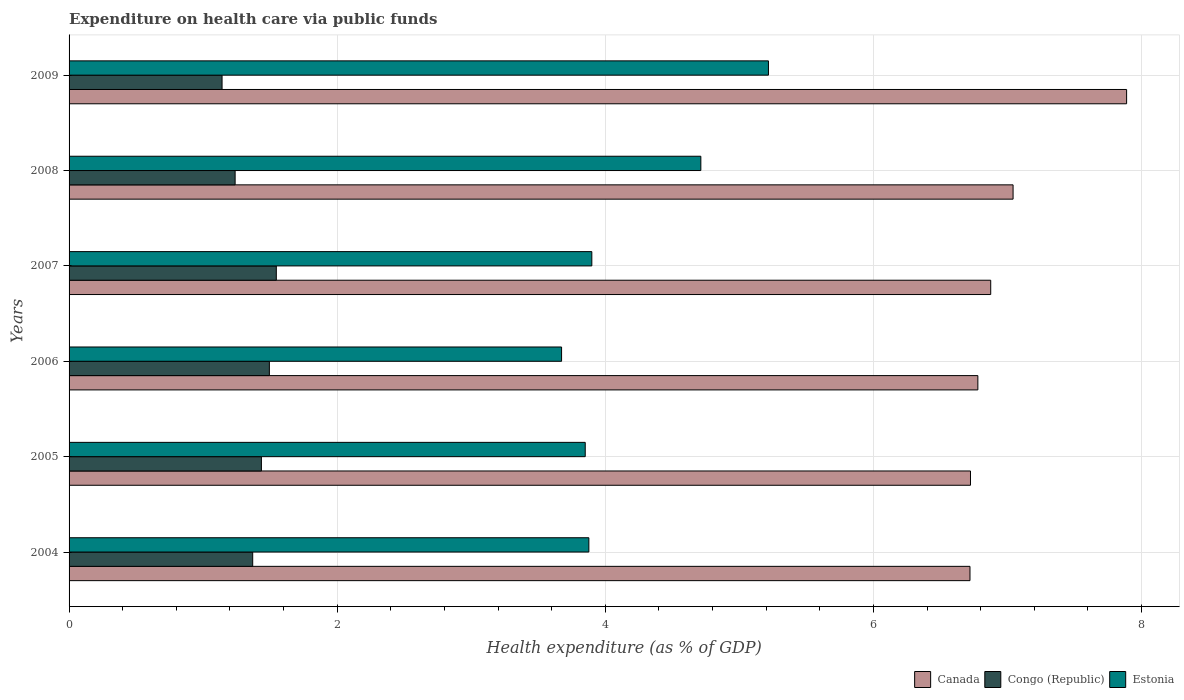How many groups of bars are there?
Keep it short and to the point. 6. Are the number of bars per tick equal to the number of legend labels?
Give a very brief answer. Yes. How many bars are there on the 5th tick from the top?
Ensure brevity in your answer.  3. In how many cases, is the number of bars for a given year not equal to the number of legend labels?
Keep it short and to the point. 0. What is the expenditure made on health care in Congo (Republic) in 2007?
Make the answer very short. 1.55. Across all years, what is the maximum expenditure made on health care in Estonia?
Ensure brevity in your answer.  5.22. Across all years, what is the minimum expenditure made on health care in Congo (Republic)?
Your answer should be very brief. 1.14. In which year was the expenditure made on health care in Canada maximum?
Offer a terse response. 2009. What is the total expenditure made on health care in Congo (Republic) in the graph?
Your answer should be very brief. 8.22. What is the difference between the expenditure made on health care in Canada in 2004 and that in 2005?
Your response must be concise. -0. What is the difference between the expenditure made on health care in Estonia in 2006 and the expenditure made on health care in Congo (Republic) in 2009?
Your response must be concise. 2.53. What is the average expenditure made on health care in Estonia per year?
Your answer should be compact. 4.2. In the year 2004, what is the difference between the expenditure made on health care in Congo (Republic) and expenditure made on health care in Estonia?
Provide a succinct answer. -2.51. In how many years, is the expenditure made on health care in Estonia greater than 6 %?
Make the answer very short. 0. What is the ratio of the expenditure made on health care in Estonia in 2008 to that in 2009?
Offer a terse response. 0.9. What is the difference between the highest and the second highest expenditure made on health care in Estonia?
Provide a succinct answer. 0.5. What is the difference between the highest and the lowest expenditure made on health care in Estonia?
Provide a short and direct response. 1.54. What does the 2nd bar from the top in 2007 represents?
Your answer should be compact. Congo (Republic). What does the 1st bar from the bottom in 2005 represents?
Provide a short and direct response. Canada. How many bars are there?
Ensure brevity in your answer.  18. Are the values on the major ticks of X-axis written in scientific E-notation?
Ensure brevity in your answer.  No. Does the graph contain any zero values?
Ensure brevity in your answer.  No. How many legend labels are there?
Provide a succinct answer. 3. What is the title of the graph?
Make the answer very short. Expenditure on health care via public funds. What is the label or title of the X-axis?
Ensure brevity in your answer.  Health expenditure (as % of GDP). What is the label or title of the Y-axis?
Your answer should be very brief. Years. What is the Health expenditure (as % of GDP) of Canada in 2004?
Offer a very short reply. 6.72. What is the Health expenditure (as % of GDP) of Congo (Republic) in 2004?
Offer a terse response. 1.37. What is the Health expenditure (as % of GDP) of Estonia in 2004?
Give a very brief answer. 3.88. What is the Health expenditure (as % of GDP) in Canada in 2005?
Provide a succinct answer. 6.72. What is the Health expenditure (as % of GDP) of Congo (Republic) in 2005?
Keep it short and to the point. 1.43. What is the Health expenditure (as % of GDP) of Estonia in 2005?
Your answer should be compact. 3.85. What is the Health expenditure (as % of GDP) in Canada in 2006?
Ensure brevity in your answer.  6.78. What is the Health expenditure (as % of GDP) in Congo (Republic) in 2006?
Offer a terse response. 1.49. What is the Health expenditure (as % of GDP) of Estonia in 2006?
Provide a short and direct response. 3.67. What is the Health expenditure (as % of GDP) in Canada in 2007?
Offer a terse response. 6.87. What is the Health expenditure (as % of GDP) of Congo (Republic) in 2007?
Ensure brevity in your answer.  1.55. What is the Health expenditure (as % of GDP) of Estonia in 2007?
Make the answer very short. 3.9. What is the Health expenditure (as % of GDP) in Canada in 2008?
Offer a very short reply. 7.04. What is the Health expenditure (as % of GDP) of Congo (Republic) in 2008?
Ensure brevity in your answer.  1.24. What is the Health expenditure (as % of GDP) in Estonia in 2008?
Make the answer very short. 4.71. What is the Health expenditure (as % of GDP) in Canada in 2009?
Offer a very short reply. 7.89. What is the Health expenditure (as % of GDP) in Congo (Republic) in 2009?
Provide a succinct answer. 1.14. What is the Health expenditure (as % of GDP) of Estonia in 2009?
Your response must be concise. 5.22. Across all years, what is the maximum Health expenditure (as % of GDP) of Canada?
Your answer should be very brief. 7.89. Across all years, what is the maximum Health expenditure (as % of GDP) in Congo (Republic)?
Make the answer very short. 1.55. Across all years, what is the maximum Health expenditure (as % of GDP) of Estonia?
Make the answer very short. 5.22. Across all years, what is the minimum Health expenditure (as % of GDP) in Canada?
Ensure brevity in your answer.  6.72. Across all years, what is the minimum Health expenditure (as % of GDP) in Congo (Republic)?
Provide a succinct answer. 1.14. Across all years, what is the minimum Health expenditure (as % of GDP) of Estonia?
Offer a very short reply. 3.67. What is the total Health expenditure (as % of GDP) of Canada in the graph?
Make the answer very short. 42.03. What is the total Health expenditure (as % of GDP) of Congo (Republic) in the graph?
Your response must be concise. 8.22. What is the total Health expenditure (as % of GDP) in Estonia in the graph?
Your response must be concise. 25.23. What is the difference between the Health expenditure (as % of GDP) of Canada in 2004 and that in 2005?
Provide a succinct answer. -0. What is the difference between the Health expenditure (as % of GDP) in Congo (Republic) in 2004 and that in 2005?
Give a very brief answer. -0.06. What is the difference between the Health expenditure (as % of GDP) in Estonia in 2004 and that in 2005?
Ensure brevity in your answer.  0.03. What is the difference between the Health expenditure (as % of GDP) of Canada in 2004 and that in 2006?
Offer a terse response. -0.06. What is the difference between the Health expenditure (as % of GDP) of Congo (Republic) in 2004 and that in 2006?
Your response must be concise. -0.12. What is the difference between the Health expenditure (as % of GDP) of Estonia in 2004 and that in 2006?
Offer a terse response. 0.2. What is the difference between the Health expenditure (as % of GDP) of Canada in 2004 and that in 2007?
Give a very brief answer. -0.15. What is the difference between the Health expenditure (as % of GDP) in Congo (Republic) in 2004 and that in 2007?
Ensure brevity in your answer.  -0.18. What is the difference between the Health expenditure (as % of GDP) of Estonia in 2004 and that in 2007?
Provide a succinct answer. -0.02. What is the difference between the Health expenditure (as % of GDP) in Canada in 2004 and that in 2008?
Ensure brevity in your answer.  -0.32. What is the difference between the Health expenditure (as % of GDP) of Congo (Republic) in 2004 and that in 2008?
Your answer should be very brief. 0.13. What is the difference between the Health expenditure (as % of GDP) in Estonia in 2004 and that in 2008?
Your answer should be very brief. -0.84. What is the difference between the Health expenditure (as % of GDP) of Canada in 2004 and that in 2009?
Your response must be concise. -1.17. What is the difference between the Health expenditure (as % of GDP) in Congo (Republic) in 2004 and that in 2009?
Your answer should be very brief. 0.23. What is the difference between the Health expenditure (as % of GDP) in Estonia in 2004 and that in 2009?
Your answer should be very brief. -1.34. What is the difference between the Health expenditure (as % of GDP) of Canada in 2005 and that in 2006?
Provide a succinct answer. -0.06. What is the difference between the Health expenditure (as % of GDP) of Congo (Republic) in 2005 and that in 2006?
Ensure brevity in your answer.  -0.06. What is the difference between the Health expenditure (as % of GDP) in Estonia in 2005 and that in 2006?
Ensure brevity in your answer.  0.18. What is the difference between the Health expenditure (as % of GDP) in Canada in 2005 and that in 2007?
Ensure brevity in your answer.  -0.15. What is the difference between the Health expenditure (as % of GDP) of Congo (Republic) in 2005 and that in 2007?
Your answer should be very brief. -0.11. What is the difference between the Health expenditure (as % of GDP) of Estonia in 2005 and that in 2007?
Offer a very short reply. -0.05. What is the difference between the Health expenditure (as % of GDP) in Canada in 2005 and that in 2008?
Provide a succinct answer. -0.32. What is the difference between the Health expenditure (as % of GDP) in Congo (Republic) in 2005 and that in 2008?
Offer a very short reply. 0.2. What is the difference between the Health expenditure (as % of GDP) of Estonia in 2005 and that in 2008?
Your answer should be compact. -0.86. What is the difference between the Health expenditure (as % of GDP) in Canada in 2005 and that in 2009?
Ensure brevity in your answer.  -1.16. What is the difference between the Health expenditure (as % of GDP) in Congo (Republic) in 2005 and that in 2009?
Ensure brevity in your answer.  0.29. What is the difference between the Health expenditure (as % of GDP) of Estonia in 2005 and that in 2009?
Offer a terse response. -1.37. What is the difference between the Health expenditure (as % of GDP) in Canada in 2006 and that in 2007?
Provide a succinct answer. -0.1. What is the difference between the Health expenditure (as % of GDP) of Congo (Republic) in 2006 and that in 2007?
Offer a terse response. -0.05. What is the difference between the Health expenditure (as % of GDP) in Estonia in 2006 and that in 2007?
Your response must be concise. -0.23. What is the difference between the Health expenditure (as % of GDP) in Canada in 2006 and that in 2008?
Offer a very short reply. -0.26. What is the difference between the Health expenditure (as % of GDP) in Congo (Republic) in 2006 and that in 2008?
Your answer should be compact. 0.26. What is the difference between the Health expenditure (as % of GDP) of Estonia in 2006 and that in 2008?
Ensure brevity in your answer.  -1.04. What is the difference between the Health expenditure (as % of GDP) of Canada in 2006 and that in 2009?
Provide a succinct answer. -1.11. What is the difference between the Health expenditure (as % of GDP) of Congo (Republic) in 2006 and that in 2009?
Keep it short and to the point. 0.35. What is the difference between the Health expenditure (as % of GDP) in Estonia in 2006 and that in 2009?
Offer a very short reply. -1.54. What is the difference between the Health expenditure (as % of GDP) of Canada in 2007 and that in 2008?
Your answer should be very brief. -0.17. What is the difference between the Health expenditure (as % of GDP) of Congo (Republic) in 2007 and that in 2008?
Your answer should be very brief. 0.31. What is the difference between the Health expenditure (as % of GDP) of Estonia in 2007 and that in 2008?
Your response must be concise. -0.81. What is the difference between the Health expenditure (as % of GDP) of Canada in 2007 and that in 2009?
Offer a terse response. -1.01. What is the difference between the Health expenditure (as % of GDP) in Congo (Republic) in 2007 and that in 2009?
Offer a terse response. 0.4. What is the difference between the Health expenditure (as % of GDP) in Estonia in 2007 and that in 2009?
Provide a short and direct response. -1.32. What is the difference between the Health expenditure (as % of GDP) in Canada in 2008 and that in 2009?
Offer a very short reply. -0.85. What is the difference between the Health expenditure (as % of GDP) in Congo (Republic) in 2008 and that in 2009?
Offer a very short reply. 0.1. What is the difference between the Health expenditure (as % of GDP) of Estonia in 2008 and that in 2009?
Ensure brevity in your answer.  -0.5. What is the difference between the Health expenditure (as % of GDP) of Canada in 2004 and the Health expenditure (as % of GDP) of Congo (Republic) in 2005?
Make the answer very short. 5.29. What is the difference between the Health expenditure (as % of GDP) in Canada in 2004 and the Health expenditure (as % of GDP) in Estonia in 2005?
Offer a very short reply. 2.87. What is the difference between the Health expenditure (as % of GDP) in Congo (Republic) in 2004 and the Health expenditure (as % of GDP) in Estonia in 2005?
Keep it short and to the point. -2.48. What is the difference between the Health expenditure (as % of GDP) of Canada in 2004 and the Health expenditure (as % of GDP) of Congo (Republic) in 2006?
Your answer should be compact. 5.23. What is the difference between the Health expenditure (as % of GDP) in Canada in 2004 and the Health expenditure (as % of GDP) in Estonia in 2006?
Offer a very short reply. 3.05. What is the difference between the Health expenditure (as % of GDP) of Congo (Republic) in 2004 and the Health expenditure (as % of GDP) of Estonia in 2006?
Provide a succinct answer. -2.3. What is the difference between the Health expenditure (as % of GDP) in Canada in 2004 and the Health expenditure (as % of GDP) in Congo (Republic) in 2007?
Your answer should be compact. 5.17. What is the difference between the Health expenditure (as % of GDP) of Canada in 2004 and the Health expenditure (as % of GDP) of Estonia in 2007?
Keep it short and to the point. 2.82. What is the difference between the Health expenditure (as % of GDP) in Congo (Republic) in 2004 and the Health expenditure (as % of GDP) in Estonia in 2007?
Your answer should be compact. -2.53. What is the difference between the Health expenditure (as % of GDP) in Canada in 2004 and the Health expenditure (as % of GDP) in Congo (Republic) in 2008?
Offer a very short reply. 5.48. What is the difference between the Health expenditure (as % of GDP) in Canada in 2004 and the Health expenditure (as % of GDP) in Estonia in 2008?
Your answer should be compact. 2.01. What is the difference between the Health expenditure (as % of GDP) of Congo (Republic) in 2004 and the Health expenditure (as % of GDP) of Estonia in 2008?
Offer a very short reply. -3.34. What is the difference between the Health expenditure (as % of GDP) of Canada in 2004 and the Health expenditure (as % of GDP) of Congo (Republic) in 2009?
Offer a very short reply. 5.58. What is the difference between the Health expenditure (as % of GDP) in Canada in 2004 and the Health expenditure (as % of GDP) in Estonia in 2009?
Your answer should be compact. 1.5. What is the difference between the Health expenditure (as % of GDP) in Congo (Republic) in 2004 and the Health expenditure (as % of GDP) in Estonia in 2009?
Provide a succinct answer. -3.85. What is the difference between the Health expenditure (as % of GDP) in Canada in 2005 and the Health expenditure (as % of GDP) in Congo (Republic) in 2006?
Your response must be concise. 5.23. What is the difference between the Health expenditure (as % of GDP) of Canada in 2005 and the Health expenditure (as % of GDP) of Estonia in 2006?
Ensure brevity in your answer.  3.05. What is the difference between the Health expenditure (as % of GDP) in Congo (Republic) in 2005 and the Health expenditure (as % of GDP) in Estonia in 2006?
Your answer should be compact. -2.24. What is the difference between the Health expenditure (as % of GDP) of Canada in 2005 and the Health expenditure (as % of GDP) of Congo (Republic) in 2007?
Make the answer very short. 5.18. What is the difference between the Health expenditure (as % of GDP) in Canada in 2005 and the Health expenditure (as % of GDP) in Estonia in 2007?
Your answer should be very brief. 2.82. What is the difference between the Health expenditure (as % of GDP) of Congo (Republic) in 2005 and the Health expenditure (as % of GDP) of Estonia in 2007?
Provide a short and direct response. -2.46. What is the difference between the Health expenditure (as % of GDP) of Canada in 2005 and the Health expenditure (as % of GDP) of Congo (Republic) in 2008?
Provide a short and direct response. 5.49. What is the difference between the Health expenditure (as % of GDP) in Canada in 2005 and the Health expenditure (as % of GDP) in Estonia in 2008?
Give a very brief answer. 2.01. What is the difference between the Health expenditure (as % of GDP) in Congo (Republic) in 2005 and the Health expenditure (as % of GDP) in Estonia in 2008?
Your answer should be very brief. -3.28. What is the difference between the Health expenditure (as % of GDP) of Canada in 2005 and the Health expenditure (as % of GDP) of Congo (Republic) in 2009?
Offer a very short reply. 5.58. What is the difference between the Health expenditure (as % of GDP) of Canada in 2005 and the Health expenditure (as % of GDP) of Estonia in 2009?
Offer a terse response. 1.51. What is the difference between the Health expenditure (as % of GDP) of Congo (Republic) in 2005 and the Health expenditure (as % of GDP) of Estonia in 2009?
Make the answer very short. -3.78. What is the difference between the Health expenditure (as % of GDP) in Canada in 2006 and the Health expenditure (as % of GDP) in Congo (Republic) in 2007?
Your answer should be very brief. 5.23. What is the difference between the Health expenditure (as % of GDP) in Canada in 2006 and the Health expenditure (as % of GDP) in Estonia in 2007?
Your answer should be very brief. 2.88. What is the difference between the Health expenditure (as % of GDP) of Congo (Republic) in 2006 and the Health expenditure (as % of GDP) of Estonia in 2007?
Your response must be concise. -2.41. What is the difference between the Health expenditure (as % of GDP) of Canada in 2006 and the Health expenditure (as % of GDP) of Congo (Republic) in 2008?
Your answer should be compact. 5.54. What is the difference between the Health expenditure (as % of GDP) in Canada in 2006 and the Health expenditure (as % of GDP) in Estonia in 2008?
Provide a short and direct response. 2.07. What is the difference between the Health expenditure (as % of GDP) of Congo (Republic) in 2006 and the Health expenditure (as % of GDP) of Estonia in 2008?
Provide a short and direct response. -3.22. What is the difference between the Health expenditure (as % of GDP) of Canada in 2006 and the Health expenditure (as % of GDP) of Congo (Republic) in 2009?
Your response must be concise. 5.64. What is the difference between the Health expenditure (as % of GDP) in Canada in 2006 and the Health expenditure (as % of GDP) in Estonia in 2009?
Your answer should be very brief. 1.56. What is the difference between the Health expenditure (as % of GDP) in Congo (Republic) in 2006 and the Health expenditure (as % of GDP) in Estonia in 2009?
Your answer should be very brief. -3.72. What is the difference between the Health expenditure (as % of GDP) in Canada in 2007 and the Health expenditure (as % of GDP) in Congo (Republic) in 2008?
Your answer should be compact. 5.64. What is the difference between the Health expenditure (as % of GDP) in Canada in 2007 and the Health expenditure (as % of GDP) in Estonia in 2008?
Your response must be concise. 2.16. What is the difference between the Health expenditure (as % of GDP) of Congo (Republic) in 2007 and the Health expenditure (as % of GDP) of Estonia in 2008?
Keep it short and to the point. -3.17. What is the difference between the Health expenditure (as % of GDP) in Canada in 2007 and the Health expenditure (as % of GDP) in Congo (Republic) in 2009?
Ensure brevity in your answer.  5.73. What is the difference between the Health expenditure (as % of GDP) of Canada in 2007 and the Health expenditure (as % of GDP) of Estonia in 2009?
Keep it short and to the point. 1.66. What is the difference between the Health expenditure (as % of GDP) of Congo (Republic) in 2007 and the Health expenditure (as % of GDP) of Estonia in 2009?
Offer a very short reply. -3.67. What is the difference between the Health expenditure (as % of GDP) in Canada in 2008 and the Health expenditure (as % of GDP) in Congo (Republic) in 2009?
Make the answer very short. 5.9. What is the difference between the Health expenditure (as % of GDP) in Canada in 2008 and the Health expenditure (as % of GDP) in Estonia in 2009?
Offer a terse response. 1.82. What is the difference between the Health expenditure (as % of GDP) of Congo (Republic) in 2008 and the Health expenditure (as % of GDP) of Estonia in 2009?
Keep it short and to the point. -3.98. What is the average Health expenditure (as % of GDP) of Canada per year?
Provide a short and direct response. 7. What is the average Health expenditure (as % of GDP) in Congo (Republic) per year?
Provide a succinct answer. 1.37. What is the average Health expenditure (as % of GDP) in Estonia per year?
Keep it short and to the point. 4.2. In the year 2004, what is the difference between the Health expenditure (as % of GDP) in Canada and Health expenditure (as % of GDP) in Congo (Republic)?
Your response must be concise. 5.35. In the year 2004, what is the difference between the Health expenditure (as % of GDP) of Canada and Health expenditure (as % of GDP) of Estonia?
Provide a short and direct response. 2.84. In the year 2004, what is the difference between the Health expenditure (as % of GDP) in Congo (Republic) and Health expenditure (as % of GDP) in Estonia?
Your answer should be compact. -2.51. In the year 2005, what is the difference between the Health expenditure (as % of GDP) of Canada and Health expenditure (as % of GDP) of Congo (Republic)?
Your response must be concise. 5.29. In the year 2005, what is the difference between the Health expenditure (as % of GDP) of Canada and Health expenditure (as % of GDP) of Estonia?
Provide a short and direct response. 2.87. In the year 2005, what is the difference between the Health expenditure (as % of GDP) in Congo (Republic) and Health expenditure (as % of GDP) in Estonia?
Offer a very short reply. -2.42. In the year 2006, what is the difference between the Health expenditure (as % of GDP) of Canada and Health expenditure (as % of GDP) of Congo (Republic)?
Offer a very short reply. 5.28. In the year 2006, what is the difference between the Health expenditure (as % of GDP) in Canada and Health expenditure (as % of GDP) in Estonia?
Ensure brevity in your answer.  3.11. In the year 2006, what is the difference between the Health expenditure (as % of GDP) of Congo (Republic) and Health expenditure (as % of GDP) of Estonia?
Provide a short and direct response. -2.18. In the year 2007, what is the difference between the Health expenditure (as % of GDP) in Canada and Health expenditure (as % of GDP) in Congo (Republic)?
Your answer should be compact. 5.33. In the year 2007, what is the difference between the Health expenditure (as % of GDP) in Canada and Health expenditure (as % of GDP) in Estonia?
Provide a succinct answer. 2.98. In the year 2007, what is the difference between the Health expenditure (as % of GDP) of Congo (Republic) and Health expenditure (as % of GDP) of Estonia?
Provide a succinct answer. -2.35. In the year 2008, what is the difference between the Health expenditure (as % of GDP) of Canada and Health expenditure (as % of GDP) of Congo (Republic)?
Your answer should be very brief. 5.8. In the year 2008, what is the difference between the Health expenditure (as % of GDP) in Canada and Health expenditure (as % of GDP) in Estonia?
Provide a short and direct response. 2.33. In the year 2008, what is the difference between the Health expenditure (as % of GDP) in Congo (Republic) and Health expenditure (as % of GDP) in Estonia?
Ensure brevity in your answer.  -3.47. In the year 2009, what is the difference between the Health expenditure (as % of GDP) in Canada and Health expenditure (as % of GDP) in Congo (Republic)?
Offer a very short reply. 6.75. In the year 2009, what is the difference between the Health expenditure (as % of GDP) in Canada and Health expenditure (as % of GDP) in Estonia?
Keep it short and to the point. 2.67. In the year 2009, what is the difference between the Health expenditure (as % of GDP) in Congo (Republic) and Health expenditure (as % of GDP) in Estonia?
Your answer should be compact. -4.08. What is the ratio of the Health expenditure (as % of GDP) in Canada in 2004 to that in 2005?
Offer a very short reply. 1. What is the ratio of the Health expenditure (as % of GDP) of Congo (Republic) in 2004 to that in 2005?
Make the answer very short. 0.95. What is the ratio of the Health expenditure (as % of GDP) of Estonia in 2004 to that in 2005?
Offer a very short reply. 1.01. What is the ratio of the Health expenditure (as % of GDP) of Congo (Republic) in 2004 to that in 2006?
Offer a very short reply. 0.92. What is the ratio of the Health expenditure (as % of GDP) of Estonia in 2004 to that in 2006?
Keep it short and to the point. 1.06. What is the ratio of the Health expenditure (as % of GDP) of Canada in 2004 to that in 2007?
Offer a very short reply. 0.98. What is the ratio of the Health expenditure (as % of GDP) in Congo (Republic) in 2004 to that in 2007?
Your answer should be very brief. 0.89. What is the ratio of the Health expenditure (as % of GDP) in Canada in 2004 to that in 2008?
Ensure brevity in your answer.  0.95. What is the ratio of the Health expenditure (as % of GDP) in Congo (Republic) in 2004 to that in 2008?
Offer a terse response. 1.11. What is the ratio of the Health expenditure (as % of GDP) in Estonia in 2004 to that in 2008?
Give a very brief answer. 0.82. What is the ratio of the Health expenditure (as % of GDP) of Canada in 2004 to that in 2009?
Make the answer very short. 0.85. What is the ratio of the Health expenditure (as % of GDP) in Congo (Republic) in 2004 to that in 2009?
Your response must be concise. 1.2. What is the ratio of the Health expenditure (as % of GDP) in Estonia in 2004 to that in 2009?
Provide a short and direct response. 0.74. What is the ratio of the Health expenditure (as % of GDP) of Congo (Republic) in 2005 to that in 2006?
Your response must be concise. 0.96. What is the ratio of the Health expenditure (as % of GDP) of Estonia in 2005 to that in 2006?
Provide a short and direct response. 1.05. What is the ratio of the Health expenditure (as % of GDP) of Congo (Republic) in 2005 to that in 2007?
Provide a short and direct response. 0.93. What is the ratio of the Health expenditure (as % of GDP) in Estonia in 2005 to that in 2007?
Keep it short and to the point. 0.99. What is the ratio of the Health expenditure (as % of GDP) in Canada in 2005 to that in 2008?
Ensure brevity in your answer.  0.95. What is the ratio of the Health expenditure (as % of GDP) of Congo (Republic) in 2005 to that in 2008?
Ensure brevity in your answer.  1.16. What is the ratio of the Health expenditure (as % of GDP) of Estonia in 2005 to that in 2008?
Provide a short and direct response. 0.82. What is the ratio of the Health expenditure (as % of GDP) of Canada in 2005 to that in 2009?
Your response must be concise. 0.85. What is the ratio of the Health expenditure (as % of GDP) in Congo (Republic) in 2005 to that in 2009?
Your answer should be very brief. 1.26. What is the ratio of the Health expenditure (as % of GDP) of Estonia in 2005 to that in 2009?
Make the answer very short. 0.74. What is the ratio of the Health expenditure (as % of GDP) in Canada in 2006 to that in 2007?
Provide a short and direct response. 0.99. What is the ratio of the Health expenditure (as % of GDP) of Congo (Republic) in 2006 to that in 2007?
Ensure brevity in your answer.  0.97. What is the ratio of the Health expenditure (as % of GDP) of Estonia in 2006 to that in 2007?
Your response must be concise. 0.94. What is the ratio of the Health expenditure (as % of GDP) in Canada in 2006 to that in 2008?
Offer a very short reply. 0.96. What is the ratio of the Health expenditure (as % of GDP) of Congo (Republic) in 2006 to that in 2008?
Provide a succinct answer. 1.21. What is the ratio of the Health expenditure (as % of GDP) of Estonia in 2006 to that in 2008?
Provide a succinct answer. 0.78. What is the ratio of the Health expenditure (as % of GDP) in Canada in 2006 to that in 2009?
Your response must be concise. 0.86. What is the ratio of the Health expenditure (as % of GDP) of Congo (Republic) in 2006 to that in 2009?
Ensure brevity in your answer.  1.31. What is the ratio of the Health expenditure (as % of GDP) of Estonia in 2006 to that in 2009?
Offer a terse response. 0.7. What is the ratio of the Health expenditure (as % of GDP) in Canada in 2007 to that in 2008?
Your response must be concise. 0.98. What is the ratio of the Health expenditure (as % of GDP) in Congo (Republic) in 2007 to that in 2008?
Give a very brief answer. 1.25. What is the ratio of the Health expenditure (as % of GDP) of Estonia in 2007 to that in 2008?
Provide a succinct answer. 0.83. What is the ratio of the Health expenditure (as % of GDP) of Canada in 2007 to that in 2009?
Ensure brevity in your answer.  0.87. What is the ratio of the Health expenditure (as % of GDP) of Congo (Republic) in 2007 to that in 2009?
Keep it short and to the point. 1.35. What is the ratio of the Health expenditure (as % of GDP) of Estonia in 2007 to that in 2009?
Keep it short and to the point. 0.75. What is the ratio of the Health expenditure (as % of GDP) in Canada in 2008 to that in 2009?
Give a very brief answer. 0.89. What is the ratio of the Health expenditure (as % of GDP) in Congo (Republic) in 2008 to that in 2009?
Your response must be concise. 1.09. What is the ratio of the Health expenditure (as % of GDP) in Estonia in 2008 to that in 2009?
Provide a short and direct response. 0.9. What is the difference between the highest and the second highest Health expenditure (as % of GDP) in Canada?
Provide a short and direct response. 0.85. What is the difference between the highest and the second highest Health expenditure (as % of GDP) of Congo (Republic)?
Make the answer very short. 0.05. What is the difference between the highest and the second highest Health expenditure (as % of GDP) of Estonia?
Offer a very short reply. 0.5. What is the difference between the highest and the lowest Health expenditure (as % of GDP) in Canada?
Offer a very short reply. 1.17. What is the difference between the highest and the lowest Health expenditure (as % of GDP) of Congo (Republic)?
Provide a succinct answer. 0.4. What is the difference between the highest and the lowest Health expenditure (as % of GDP) of Estonia?
Your response must be concise. 1.54. 